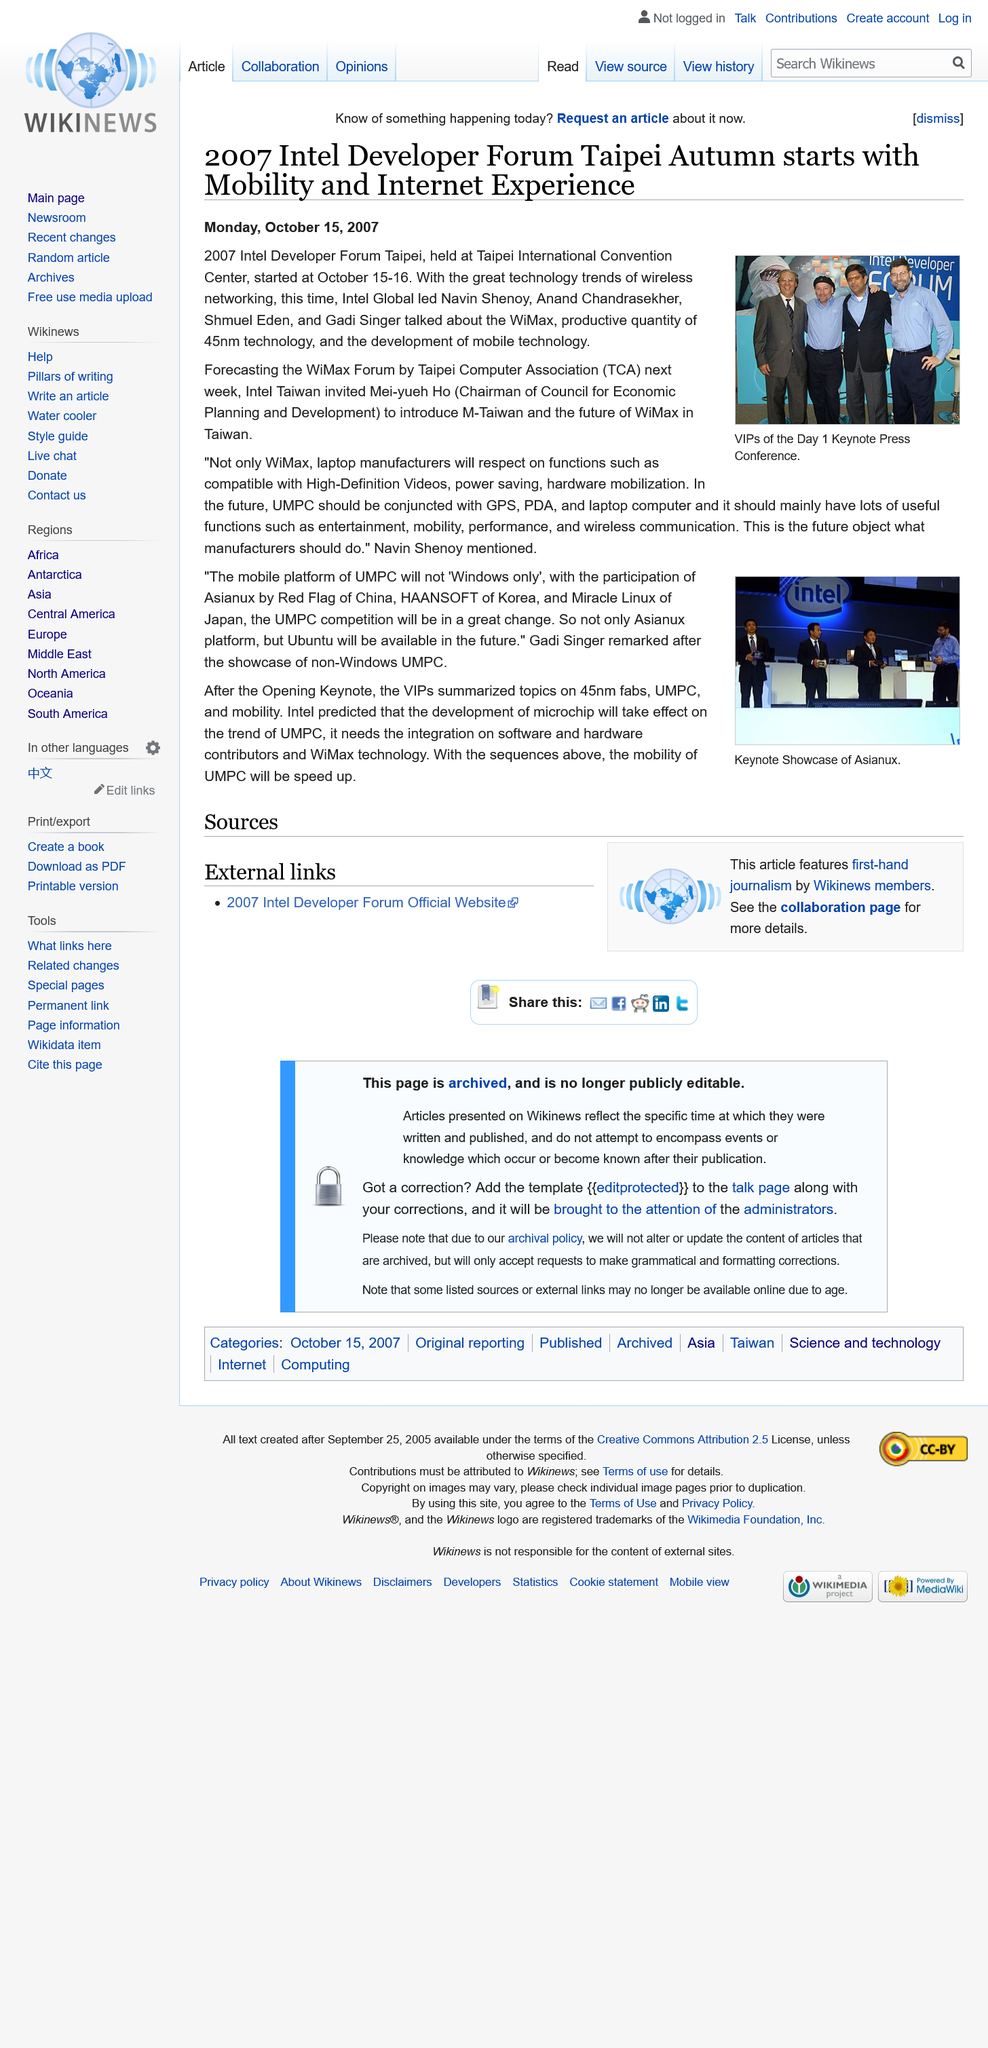Identify some key points in this picture. The 2007 Intel Developer Forum Taipei began with a focus on Mobility and Internet Experience. The article mentions the participation of China, Korea, and Japan. The people in the picture were VIPs of the Day 1 Keynote Press Conference. The 2007 Intel Developer Forum Taipei started on Monday, October 15, 2007. There are four people on the stage during the keynote speech. 